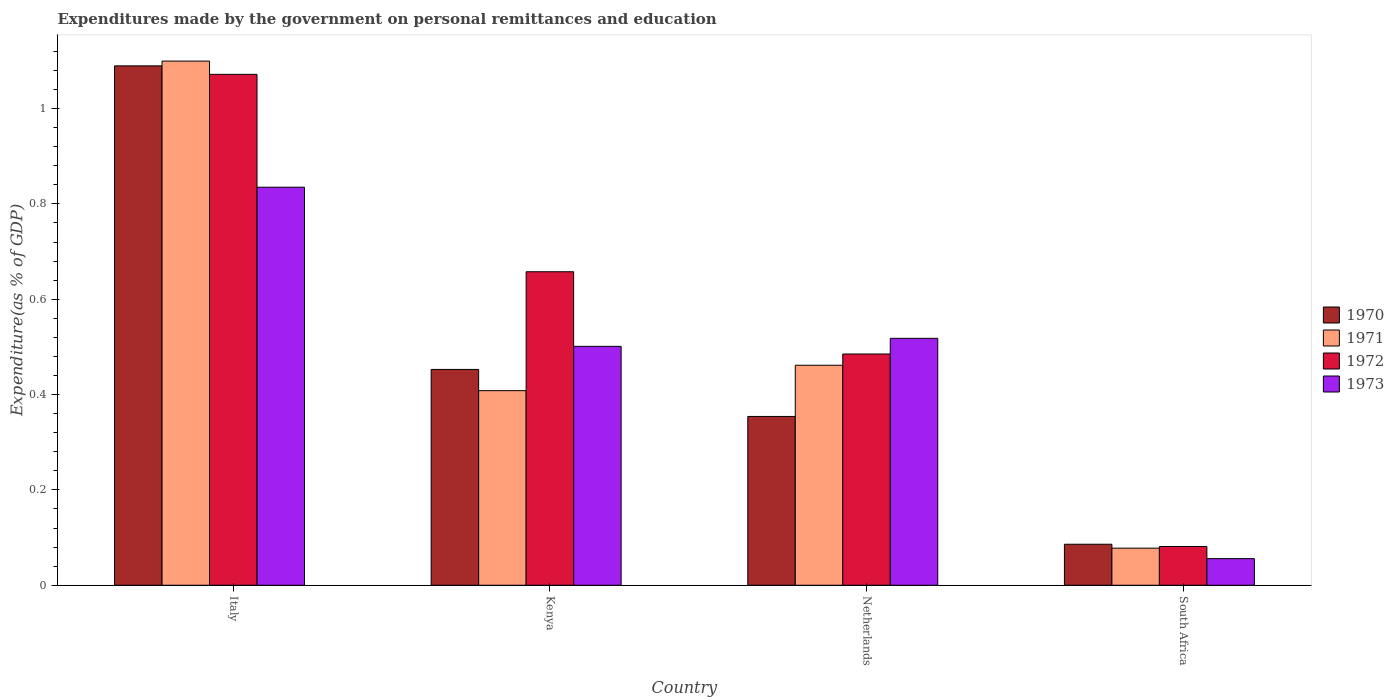How many different coloured bars are there?
Your answer should be very brief. 4. Are the number of bars per tick equal to the number of legend labels?
Provide a succinct answer. Yes. Are the number of bars on each tick of the X-axis equal?
Keep it short and to the point. Yes. How many bars are there on the 1st tick from the left?
Offer a very short reply. 4. How many bars are there on the 4th tick from the right?
Your response must be concise. 4. What is the label of the 4th group of bars from the left?
Make the answer very short. South Africa. What is the expenditures made by the government on personal remittances and education in 1970 in Netherlands?
Offer a terse response. 0.35. Across all countries, what is the maximum expenditures made by the government on personal remittances and education in 1972?
Your answer should be very brief. 1.07. Across all countries, what is the minimum expenditures made by the government on personal remittances and education in 1973?
Your answer should be compact. 0.06. In which country was the expenditures made by the government on personal remittances and education in 1971 minimum?
Keep it short and to the point. South Africa. What is the total expenditures made by the government on personal remittances and education in 1973 in the graph?
Give a very brief answer. 1.91. What is the difference between the expenditures made by the government on personal remittances and education in 1970 in Kenya and that in Netherlands?
Provide a succinct answer. 0.1. What is the difference between the expenditures made by the government on personal remittances and education in 1973 in Kenya and the expenditures made by the government on personal remittances and education in 1971 in Italy?
Your answer should be very brief. -0.6. What is the average expenditures made by the government on personal remittances and education in 1973 per country?
Give a very brief answer. 0.48. What is the difference between the expenditures made by the government on personal remittances and education of/in 1970 and expenditures made by the government on personal remittances and education of/in 1971 in Netherlands?
Your response must be concise. -0.11. What is the ratio of the expenditures made by the government on personal remittances and education in 1973 in Italy to that in Netherlands?
Give a very brief answer. 1.61. Is the expenditures made by the government on personal remittances and education in 1970 in Italy less than that in South Africa?
Provide a succinct answer. No. Is the difference between the expenditures made by the government on personal remittances and education in 1970 in Netherlands and South Africa greater than the difference between the expenditures made by the government on personal remittances and education in 1971 in Netherlands and South Africa?
Your answer should be compact. No. What is the difference between the highest and the second highest expenditures made by the government on personal remittances and education in 1973?
Provide a succinct answer. 0.32. What is the difference between the highest and the lowest expenditures made by the government on personal remittances and education in 1972?
Your answer should be compact. 0.99. Is the sum of the expenditures made by the government on personal remittances and education in 1970 in Kenya and Netherlands greater than the maximum expenditures made by the government on personal remittances and education in 1972 across all countries?
Give a very brief answer. No. How many bars are there?
Your response must be concise. 16. Are all the bars in the graph horizontal?
Offer a very short reply. No. Does the graph contain any zero values?
Your answer should be very brief. No. Does the graph contain grids?
Keep it short and to the point. No. Where does the legend appear in the graph?
Provide a short and direct response. Center right. How many legend labels are there?
Ensure brevity in your answer.  4. How are the legend labels stacked?
Keep it short and to the point. Vertical. What is the title of the graph?
Offer a very short reply. Expenditures made by the government on personal remittances and education. Does "1995" appear as one of the legend labels in the graph?
Your answer should be very brief. No. What is the label or title of the Y-axis?
Make the answer very short. Expenditure(as % of GDP). What is the Expenditure(as % of GDP) of 1970 in Italy?
Ensure brevity in your answer.  1.09. What is the Expenditure(as % of GDP) in 1971 in Italy?
Offer a terse response. 1.1. What is the Expenditure(as % of GDP) in 1972 in Italy?
Your answer should be compact. 1.07. What is the Expenditure(as % of GDP) of 1973 in Italy?
Your response must be concise. 0.84. What is the Expenditure(as % of GDP) in 1970 in Kenya?
Provide a short and direct response. 0.45. What is the Expenditure(as % of GDP) of 1971 in Kenya?
Your answer should be compact. 0.41. What is the Expenditure(as % of GDP) of 1972 in Kenya?
Provide a short and direct response. 0.66. What is the Expenditure(as % of GDP) of 1973 in Kenya?
Your answer should be very brief. 0.5. What is the Expenditure(as % of GDP) in 1970 in Netherlands?
Offer a very short reply. 0.35. What is the Expenditure(as % of GDP) in 1971 in Netherlands?
Provide a succinct answer. 0.46. What is the Expenditure(as % of GDP) of 1972 in Netherlands?
Offer a terse response. 0.49. What is the Expenditure(as % of GDP) of 1973 in Netherlands?
Ensure brevity in your answer.  0.52. What is the Expenditure(as % of GDP) of 1970 in South Africa?
Give a very brief answer. 0.09. What is the Expenditure(as % of GDP) in 1971 in South Africa?
Make the answer very short. 0.08. What is the Expenditure(as % of GDP) of 1972 in South Africa?
Offer a terse response. 0.08. What is the Expenditure(as % of GDP) of 1973 in South Africa?
Make the answer very short. 0.06. Across all countries, what is the maximum Expenditure(as % of GDP) of 1970?
Your answer should be compact. 1.09. Across all countries, what is the maximum Expenditure(as % of GDP) in 1971?
Provide a short and direct response. 1.1. Across all countries, what is the maximum Expenditure(as % of GDP) in 1972?
Make the answer very short. 1.07. Across all countries, what is the maximum Expenditure(as % of GDP) of 1973?
Ensure brevity in your answer.  0.84. Across all countries, what is the minimum Expenditure(as % of GDP) of 1970?
Offer a very short reply. 0.09. Across all countries, what is the minimum Expenditure(as % of GDP) of 1971?
Ensure brevity in your answer.  0.08. Across all countries, what is the minimum Expenditure(as % of GDP) of 1972?
Offer a very short reply. 0.08. Across all countries, what is the minimum Expenditure(as % of GDP) of 1973?
Your response must be concise. 0.06. What is the total Expenditure(as % of GDP) in 1970 in the graph?
Your response must be concise. 1.98. What is the total Expenditure(as % of GDP) in 1971 in the graph?
Give a very brief answer. 2.05. What is the total Expenditure(as % of GDP) of 1972 in the graph?
Ensure brevity in your answer.  2.3. What is the total Expenditure(as % of GDP) of 1973 in the graph?
Make the answer very short. 1.91. What is the difference between the Expenditure(as % of GDP) of 1970 in Italy and that in Kenya?
Ensure brevity in your answer.  0.64. What is the difference between the Expenditure(as % of GDP) of 1971 in Italy and that in Kenya?
Provide a succinct answer. 0.69. What is the difference between the Expenditure(as % of GDP) in 1972 in Italy and that in Kenya?
Make the answer very short. 0.41. What is the difference between the Expenditure(as % of GDP) of 1973 in Italy and that in Kenya?
Your answer should be very brief. 0.33. What is the difference between the Expenditure(as % of GDP) of 1970 in Italy and that in Netherlands?
Ensure brevity in your answer.  0.74. What is the difference between the Expenditure(as % of GDP) in 1971 in Italy and that in Netherlands?
Give a very brief answer. 0.64. What is the difference between the Expenditure(as % of GDP) in 1972 in Italy and that in Netherlands?
Ensure brevity in your answer.  0.59. What is the difference between the Expenditure(as % of GDP) in 1973 in Italy and that in Netherlands?
Make the answer very short. 0.32. What is the difference between the Expenditure(as % of GDP) in 1970 in Italy and that in South Africa?
Your answer should be very brief. 1. What is the difference between the Expenditure(as % of GDP) of 1971 in Italy and that in South Africa?
Provide a short and direct response. 1.02. What is the difference between the Expenditure(as % of GDP) of 1972 in Italy and that in South Africa?
Offer a very short reply. 0.99. What is the difference between the Expenditure(as % of GDP) of 1973 in Italy and that in South Africa?
Ensure brevity in your answer.  0.78. What is the difference between the Expenditure(as % of GDP) in 1970 in Kenya and that in Netherlands?
Keep it short and to the point. 0.1. What is the difference between the Expenditure(as % of GDP) in 1971 in Kenya and that in Netherlands?
Your answer should be compact. -0.05. What is the difference between the Expenditure(as % of GDP) in 1972 in Kenya and that in Netherlands?
Provide a succinct answer. 0.17. What is the difference between the Expenditure(as % of GDP) in 1973 in Kenya and that in Netherlands?
Ensure brevity in your answer.  -0.02. What is the difference between the Expenditure(as % of GDP) in 1970 in Kenya and that in South Africa?
Provide a short and direct response. 0.37. What is the difference between the Expenditure(as % of GDP) in 1971 in Kenya and that in South Africa?
Ensure brevity in your answer.  0.33. What is the difference between the Expenditure(as % of GDP) in 1972 in Kenya and that in South Africa?
Provide a short and direct response. 0.58. What is the difference between the Expenditure(as % of GDP) of 1973 in Kenya and that in South Africa?
Provide a succinct answer. 0.45. What is the difference between the Expenditure(as % of GDP) of 1970 in Netherlands and that in South Africa?
Offer a very short reply. 0.27. What is the difference between the Expenditure(as % of GDP) in 1971 in Netherlands and that in South Africa?
Your response must be concise. 0.38. What is the difference between the Expenditure(as % of GDP) of 1972 in Netherlands and that in South Africa?
Keep it short and to the point. 0.4. What is the difference between the Expenditure(as % of GDP) of 1973 in Netherlands and that in South Africa?
Provide a short and direct response. 0.46. What is the difference between the Expenditure(as % of GDP) in 1970 in Italy and the Expenditure(as % of GDP) in 1971 in Kenya?
Give a very brief answer. 0.68. What is the difference between the Expenditure(as % of GDP) in 1970 in Italy and the Expenditure(as % of GDP) in 1972 in Kenya?
Your answer should be compact. 0.43. What is the difference between the Expenditure(as % of GDP) of 1970 in Italy and the Expenditure(as % of GDP) of 1973 in Kenya?
Offer a terse response. 0.59. What is the difference between the Expenditure(as % of GDP) in 1971 in Italy and the Expenditure(as % of GDP) in 1972 in Kenya?
Provide a succinct answer. 0.44. What is the difference between the Expenditure(as % of GDP) in 1971 in Italy and the Expenditure(as % of GDP) in 1973 in Kenya?
Your answer should be very brief. 0.6. What is the difference between the Expenditure(as % of GDP) of 1972 in Italy and the Expenditure(as % of GDP) of 1973 in Kenya?
Your response must be concise. 0.57. What is the difference between the Expenditure(as % of GDP) in 1970 in Italy and the Expenditure(as % of GDP) in 1971 in Netherlands?
Your response must be concise. 0.63. What is the difference between the Expenditure(as % of GDP) of 1970 in Italy and the Expenditure(as % of GDP) of 1972 in Netherlands?
Provide a succinct answer. 0.6. What is the difference between the Expenditure(as % of GDP) of 1970 in Italy and the Expenditure(as % of GDP) of 1973 in Netherlands?
Ensure brevity in your answer.  0.57. What is the difference between the Expenditure(as % of GDP) of 1971 in Italy and the Expenditure(as % of GDP) of 1972 in Netherlands?
Offer a terse response. 0.61. What is the difference between the Expenditure(as % of GDP) of 1971 in Italy and the Expenditure(as % of GDP) of 1973 in Netherlands?
Give a very brief answer. 0.58. What is the difference between the Expenditure(as % of GDP) in 1972 in Italy and the Expenditure(as % of GDP) in 1973 in Netherlands?
Give a very brief answer. 0.55. What is the difference between the Expenditure(as % of GDP) in 1970 in Italy and the Expenditure(as % of GDP) in 1971 in South Africa?
Make the answer very short. 1.01. What is the difference between the Expenditure(as % of GDP) in 1970 in Italy and the Expenditure(as % of GDP) in 1972 in South Africa?
Your answer should be very brief. 1.01. What is the difference between the Expenditure(as % of GDP) of 1970 in Italy and the Expenditure(as % of GDP) of 1973 in South Africa?
Give a very brief answer. 1.03. What is the difference between the Expenditure(as % of GDP) of 1971 in Italy and the Expenditure(as % of GDP) of 1972 in South Africa?
Your response must be concise. 1.02. What is the difference between the Expenditure(as % of GDP) of 1971 in Italy and the Expenditure(as % of GDP) of 1973 in South Africa?
Your response must be concise. 1.04. What is the difference between the Expenditure(as % of GDP) of 1972 in Italy and the Expenditure(as % of GDP) of 1973 in South Africa?
Your answer should be compact. 1.02. What is the difference between the Expenditure(as % of GDP) in 1970 in Kenya and the Expenditure(as % of GDP) in 1971 in Netherlands?
Give a very brief answer. -0.01. What is the difference between the Expenditure(as % of GDP) of 1970 in Kenya and the Expenditure(as % of GDP) of 1972 in Netherlands?
Offer a very short reply. -0.03. What is the difference between the Expenditure(as % of GDP) in 1970 in Kenya and the Expenditure(as % of GDP) in 1973 in Netherlands?
Your response must be concise. -0.07. What is the difference between the Expenditure(as % of GDP) of 1971 in Kenya and the Expenditure(as % of GDP) of 1972 in Netherlands?
Your response must be concise. -0.08. What is the difference between the Expenditure(as % of GDP) in 1971 in Kenya and the Expenditure(as % of GDP) in 1973 in Netherlands?
Your response must be concise. -0.11. What is the difference between the Expenditure(as % of GDP) in 1972 in Kenya and the Expenditure(as % of GDP) in 1973 in Netherlands?
Offer a terse response. 0.14. What is the difference between the Expenditure(as % of GDP) in 1970 in Kenya and the Expenditure(as % of GDP) in 1971 in South Africa?
Your answer should be compact. 0.38. What is the difference between the Expenditure(as % of GDP) in 1970 in Kenya and the Expenditure(as % of GDP) in 1972 in South Africa?
Your response must be concise. 0.37. What is the difference between the Expenditure(as % of GDP) in 1970 in Kenya and the Expenditure(as % of GDP) in 1973 in South Africa?
Offer a very short reply. 0.4. What is the difference between the Expenditure(as % of GDP) of 1971 in Kenya and the Expenditure(as % of GDP) of 1972 in South Africa?
Your answer should be very brief. 0.33. What is the difference between the Expenditure(as % of GDP) in 1971 in Kenya and the Expenditure(as % of GDP) in 1973 in South Africa?
Provide a succinct answer. 0.35. What is the difference between the Expenditure(as % of GDP) of 1972 in Kenya and the Expenditure(as % of GDP) of 1973 in South Africa?
Give a very brief answer. 0.6. What is the difference between the Expenditure(as % of GDP) in 1970 in Netherlands and the Expenditure(as % of GDP) in 1971 in South Africa?
Make the answer very short. 0.28. What is the difference between the Expenditure(as % of GDP) of 1970 in Netherlands and the Expenditure(as % of GDP) of 1972 in South Africa?
Provide a succinct answer. 0.27. What is the difference between the Expenditure(as % of GDP) of 1970 in Netherlands and the Expenditure(as % of GDP) of 1973 in South Africa?
Offer a terse response. 0.3. What is the difference between the Expenditure(as % of GDP) of 1971 in Netherlands and the Expenditure(as % of GDP) of 1972 in South Africa?
Your answer should be compact. 0.38. What is the difference between the Expenditure(as % of GDP) in 1971 in Netherlands and the Expenditure(as % of GDP) in 1973 in South Africa?
Provide a succinct answer. 0.41. What is the difference between the Expenditure(as % of GDP) of 1972 in Netherlands and the Expenditure(as % of GDP) of 1973 in South Africa?
Offer a very short reply. 0.43. What is the average Expenditure(as % of GDP) of 1970 per country?
Offer a terse response. 0.5. What is the average Expenditure(as % of GDP) of 1971 per country?
Offer a terse response. 0.51. What is the average Expenditure(as % of GDP) of 1972 per country?
Keep it short and to the point. 0.57. What is the average Expenditure(as % of GDP) in 1973 per country?
Make the answer very short. 0.48. What is the difference between the Expenditure(as % of GDP) of 1970 and Expenditure(as % of GDP) of 1971 in Italy?
Offer a very short reply. -0.01. What is the difference between the Expenditure(as % of GDP) of 1970 and Expenditure(as % of GDP) of 1972 in Italy?
Offer a very short reply. 0.02. What is the difference between the Expenditure(as % of GDP) in 1970 and Expenditure(as % of GDP) in 1973 in Italy?
Offer a very short reply. 0.25. What is the difference between the Expenditure(as % of GDP) of 1971 and Expenditure(as % of GDP) of 1972 in Italy?
Offer a terse response. 0.03. What is the difference between the Expenditure(as % of GDP) of 1971 and Expenditure(as % of GDP) of 1973 in Italy?
Keep it short and to the point. 0.26. What is the difference between the Expenditure(as % of GDP) in 1972 and Expenditure(as % of GDP) in 1973 in Italy?
Provide a short and direct response. 0.24. What is the difference between the Expenditure(as % of GDP) of 1970 and Expenditure(as % of GDP) of 1971 in Kenya?
Keep it short and to the point. 0.04. What is the difference between the Expenditure(as % of GDP) of 1970 and Expenditure(as % of GDP) of 1972 in Kenya?
Your response must be concise. -0.2. What is the difference between the Expenditure(as % of GDP) of 1970 and Expenditure(as % of GDP) of 1973 in Kenya?
Give a very brief answer. -0.05. What is the difference between the Expenditure(as % of GDP) of 1971 and Expenditure(as % of GDP) of 1972 in Kenya?
Your answer should be very brief. -0.25. What is the difference between the Expenditure(as % of GDP) of 1971 and Expenditure(as % of GDP) of 1973 in Kenya?
Your answer should be very brief. -0.09. What is the difference between the Expenditure(as % of GDP) of 1972 and Expenditure(as % of GDP) of 1973 in Kenya?
Offer a very short reply. 0.16. What is the difference between the Expenditure(as % of GDP) in 1970 and Expenditure(as % of GDP) in 1971 in Netherlands?
Your response must be concise. -0.11. What is the difference between the Expenditure(as % of GDP) in 1970 and Expenditure(as % of GDP) in 1972 in Netherlands?
Your answer should be compact. -0.13. What is the difference between the Expenditure(as % of GDP) in 1970 and Expenditure(as % of GDP) in 1973 in Netherlands?
Your answer should be very brief. -0.16. What is the difference between the Expenditure(as % of GDP) in 1971 and Expenditure(as % of GDP) in 1972 in Netherlands?
Make the answer very short. -0.02. What is the difference between the Expenditure(as % of GDP) of 1971 and Expenditure(as % of GDP) of 1973 in Netherlands?
Your answer should be very brief. -0.06. What is the difference between the Expenditure(as % of GDP) in 1972 and Expenditure(as % of GDP) in 1973 in Netherlands?
Keep it short and to the point. -0.03. What is the difference between the Expenditure(as % of GDP) in 1970 and Expenditure(as % of GDP) in 1971 in South Africa?
Offer a very short reply. 0.01. What is the difference between the Expenditure(as % of GDP) of 1970 and Expenditure(as % of GDP) of 1972 in South Africa?
Your answer should be compact. 0. What is the difference between the Expenditure(as % of GDP) in 1970 and Expenditure(as % of GDP) in 1973 in South Africa?
Ensure brevity in your answer.  0.03. What is the difference between the Expenditure(as % of GDP) of 1971 and Expenditure(as % of GDP) of 1972 in South Africa?
Provide a succinct answer. -0. What is the difference between the Expenditure(as % of GDP) of 1971 and Expenditure(as % of GDP) of 1973 in South Africa?
Provide a succinct answer. 0.02. What is the difference between the Expenditure(as % of GDP) of 1972 and Expenditure(as % of GDP) of 1973 in South Africa?
Your answer should be compact. 0.03. What is the ratio of the Expenditure(as % of GDP) of 1970 in Italy to that in Kenya?
Provide a succinct answer. 2.41. What is the ratio of the Expenditure(as % of GDP) in 1971 in Italy to that in Kenya?
Provide a succinct answer. 2.69. What is the ratio of the Expenditure(as % of GDP) in 1972 in Italy to that in Kenya?
Offer a terse response. 1.63. What is the ratio of the Expenditure(as % of GDP) of 1973 in Italy to that in Kenya?
Provide a short and direct response. 1.67. What is the ratio of the Expenditure(as % of GDP) in 1970 in Italy to that in Netherlands?
Offer a terse response. 3.08. What is the ratio of the Expenditure(as % of GDP) in 1971 in Italy to that in Netherlands?
Offer a terse response. 2.38. What is the ratio of the Expenditure(as % of GDP) in 1972 in Italy to that in Netherlands?
Your answer should be compact. 2.21. What is the ratio of the Expenditure(as % of GDP) in 1973 in Italy to that in Netherlands?
Provide a succinct answer. 1.61. What is the ratio of the Expenditure(as % of GDP) in 1970 in Italy to that in South Africa?
Provide a short and direct response. 12.67. What is the ratio of the Expenditure(as % of GDP) of 1971 in Italy to that in South Africa?
Your answer should be compact. 14.13. What is the ratio of the Expenditure(as % of GDP) in 1972 in Italy to that in South Africa?
Provide a short and direct response. 13.18. What is the ratio of the Expenditure(as % of GDP) in 1973 in Italy to that in South Africa?
Your answer should be very brief. 14.96. What is the ratio of the Expenditure(as % of GDP) in 1970 in Kenya to that in Netherlands?
Make the answer very short. 1.28. What is the ratio of the Expenditure(as % of GDP) in 1971 in Kenya to that in Netherlands?
Keep it short and to the point. 0.88. What is the ratio of the Expenditure(as % of GDP) of 1972 in Kenya to that in Netherlands?
Your answer should be very brief. 1.36. What is the ratio of the Expenditure(as % of GDP) in 1973 in Kenya to that in Netherlands?
Make the answer very short. 0.97. What is the ratio of the Expenditure(as % of GDP) of 1970 in Kenya to that in South Africa?
Provide a succinct answer. 5.26. What is the ratio of the Expenditure(as % of GDP) of 1971 in Kenya to that in South Africa?
Make the answer very short. 5.25. What is the ratio of the Expenditure(as % of GDP) in 1972 in Kenya to that in South Africa?
Provide a short and direct response. 8.09. What is the ratio of the Expenditure(as % of GDP) in 1973 in Kenya to that in South Africa?
Your answer should be compact. 8.98. What is the ratio of the Expenditure(as % of GDP) in 1970 in Netherlands to that in South Africa?
Your answer should be compact. 4.12. What is the ratio of the Expenditure(as % of GDP) in 1971 in Netherlands to that in South Africa?
Make the answer very short. 5.93. What is the ratio of the Expenditure(as % of GDP) of 1972 in Netherlands to that in South Africa?
Your answer should be compact. 5.97. What is the ratio of the Expenditure(as % of GDP) of 1973 in Netherlands to that in South Africa?
Make the answer very short. 9.28. What is the difference between the highest and the second highest Expenditure(as % of GDP) of 1970?
Offer a terse response. 0.64. What is the difference between the highest and the second highest Expenditure(as % of GDP) in 1971?
Provide a succinct answer. 0.64. What is the difference between the highest and the second highest Expenditure(as % of GDP) of 1972?
Your answer should be compact. 0.41. What is the difference between the highest and the second highest Expenditure(as % of GDP) of 1973?
Offer a terse response. 0.32. What is the difference between the highest and the lowest Expenditure(as % of GDP) of 1970?
Your response must be concise. 1. What is the difference between the highest and the lowest Expenditure(as % of GDP) in 1971?
Ensure brevity in your answer.  1.02. What is the difference between the highest and the lowest Expenditure(as % of GDP) in 1972?
Give a very brief answer. 0.99. What is the difference between the highest and the lowest Expenditure(as % of GDP) in 1973?
Provide a short and direct response. 0.78. 